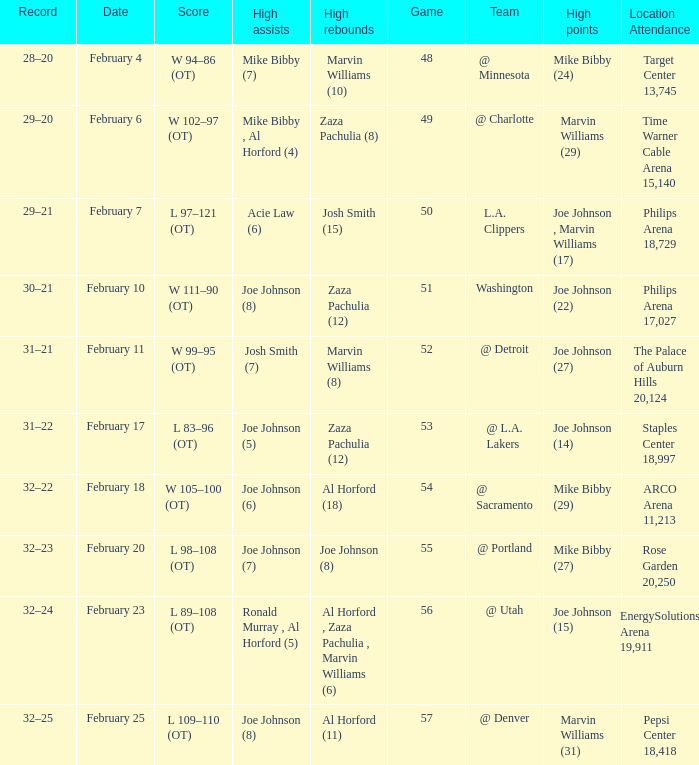Who made high assists on february 4 Mike Bibby (7). 